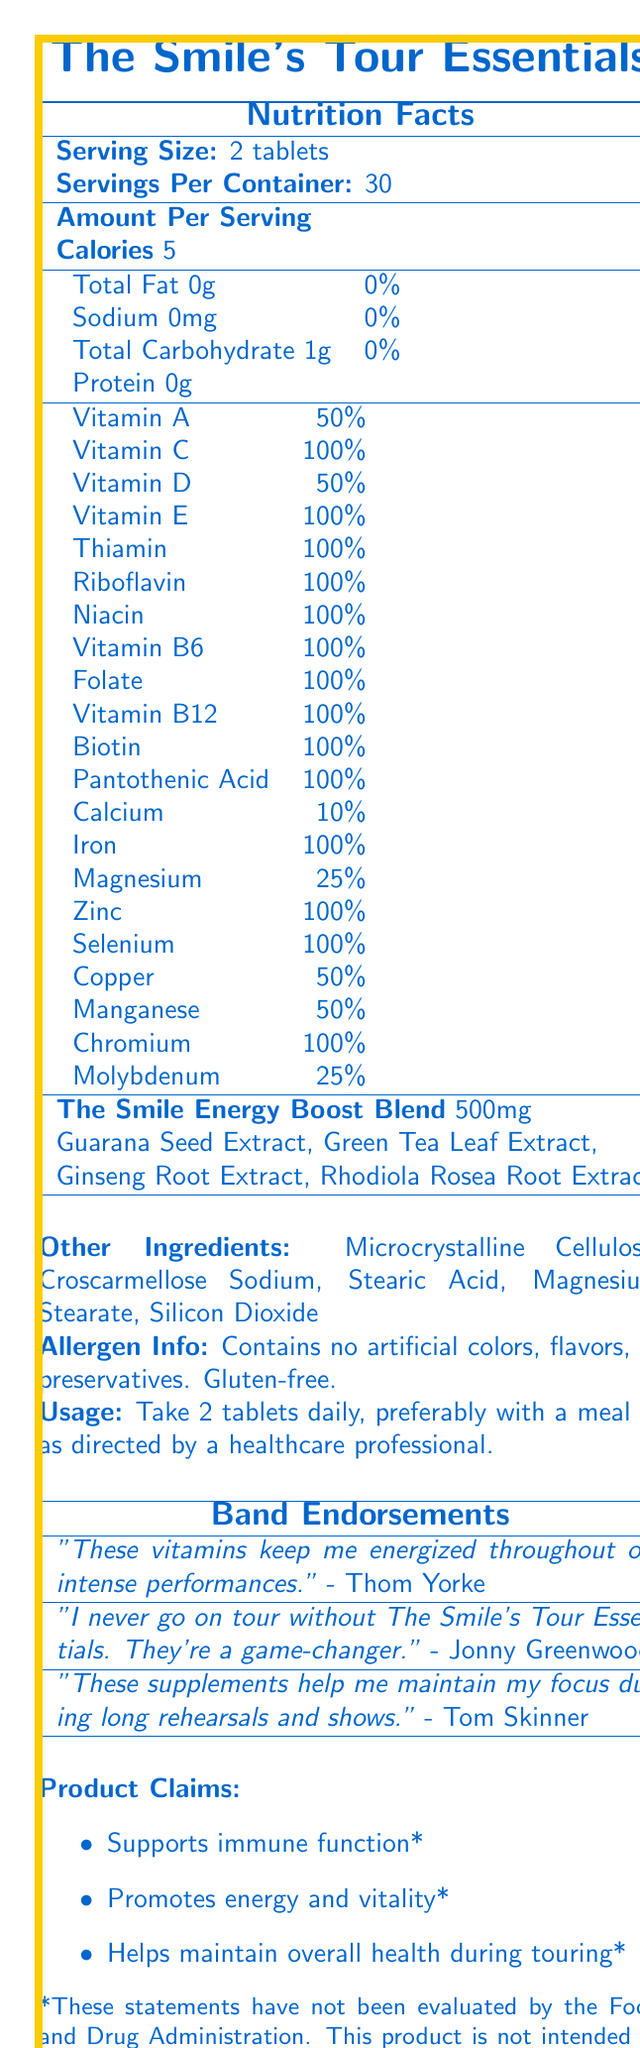when should you take The Smile's Tour Essentials tablets? The usage instructions state "Take 2 tablets daily, preferably with a meal or as directed by a healthcare professional."
Answer: Daily, preferably with a meal or as directed by a healthcare professional. how many servings per container are there? The document states that there are 30 servings per container.
Answer: 30 what is the total carbohydrate content per serving? The nutrition facts list shows that the total carbohydrate content is 1g per serving.
Answer: 1g which vitamins have 100% daily value in The Smile's Tour Essentials? The document indicates that these vitamins have a 100% daily value per serving.
Answer: Vitamin C, Vitamin E, Thiamin, Riboflavin, Niacin, Vitamin B6, Folate, Vitamin B12, Biotin, Pantothenic Acid, Iron, Zinc, Selenium, Chromium what is included in "The Smile Energy Boost Blend"? The document lists these ingredients as part of "The Smile Energy Boost Blend."
Answer: Guarana Seed Extract, Green Tea Leaf Extract, Ginseng Root Extract, Rhodiola Rosea Root Extract what is the serving size of The Smile's Tour Essentials? A. 1 tablet B. 2 tablets C. 3 tablets D. 4 tablets The document states that the serving size is 2 tablets.
Answer: B which nutrient is NOT included in The Smile's Tour Essentials? A. Vitamin K B. Vitamin A C. Vitamin D D. Vitamin C The document lists Vitamin A, Vitamin C, and Vitamin D but does not mention Vitamin K.
Answer: A is this product gluten-free? The allergen information states that the product is gluten-free.
Answer: Yes who endorses The Smile's Tour Essentials? The document lists endorsements from members Thom Yorke, Jonny Greenwood, and Tom Skinner.
Answer: Thom Yorke, Jonny Greenwood, Tom Skinner what is the main idea of The Smile's Tour Essentials document? The document is focused on providing comprehensive information about the vitamin supplement, including its nutritional content, ingredients, endorsements, and usage guidelines.
Answer: The document provides detailed nutrition facts, usage instructions, endorsements, and product claims for a vitamin supplement marketed as "The Smile's Tour Essentials" with endorsements from band members. how much calcium is in each serving? The nutrition facts indicate that each serving contains 10% of the daily value of calcium.
Answer: 10% which extract is NOT part of The Smile Energy Boost Blend? A. Guarana Seed Extract B. Green Tea Leaf Extract C. Ginkgo Biloba Leaf Extract D. Rhodiola Rosea Root Extract The Smile Energy Boost Blend includes Guarana Seed Extract, Green Tea Leaf Extract, Ginseng Root Extract, and Rhodiola Rosea Root Extract, but not Ginkgo Biloba Leaf Extract.
Answer: C are there any artificial colors, flavors, or preservatives in this product? The allergen information mentions that the product contains no artificial colors, flavors, or preservatives.
Answer: No what elements make up the proprietary blend? The document lists the specific ingredients of the proprietary blend under "The Smile Energy Boost Blend."
Answer: The proprietary blend is made up of Guarana Seed Extract, Green Tea Leaf Extract, Ginseng Root Extract, Rhodiola Rosea Root Extract what is the total protein content per serving? The document lists that the total protein content per serving is 0g.
Answer: 0g what was Tom Skinner's quote about the product? The document attributes the quote, "These supplements help me maintain my focus during long rehearsals and shows," to Tom Skinner.
Answer: "These supplements help me maintain my focus during long rehearsals and shows." how much magnesium is in each serving? The nutrition facts indicate that each serving contains 25% of the daily value of magnesium.
Answer: 25% how many calories are in a serving of The Smile's Tour Essentials? The nutrition facts state that each serving contains 5 calories.
Answer: 5 how many tablets should you take daily? A. 1 B. 2 C. 3 D. 4 The usage instructions state to take 2 tablets daily.
Answer: B what ingredient is NOT mentioned in the document? The document does not provide enough information to determine an ingredient that is not mentioned at all.
Answer: Cannot be determined 